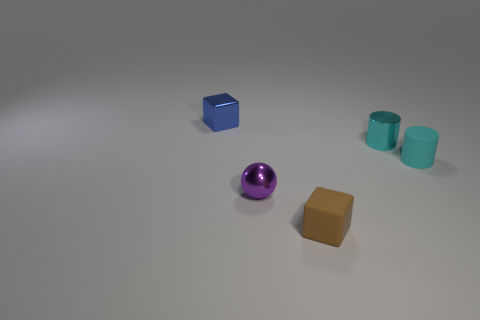How many other things are the same shape as the tiny blue thing?
Ensure brevity in your answer.  1. The small shiny object that is both on the left side of the matte cube and behind the tiny shiny sphere has what shape?
Your answer should be very brief. Cube. Are there any small cylinders left of the tiny cyan matte thing?
Make the answer very short. Yes. There is another matte object that is the same shape as the blue object; what is its size?
Keep it short and to the point. Small. Are there any other things that have the same size as the cyan rubber cylinder?
Keep it short and to the point. Yes. Does the blue object have the same shape as the tiny cyan rubber object?
Your response must be concise. No. There is a cyan cylinder that is to the left of the small matte object that is right of the small brown matte cube; how big is it?
Offer a terse response. Small. What color is the metal object that is the same shape as the cyan matte object?
Give a very brief answer. Cyan. What number of small metallic cylinders are the same color as the shiny block?
Make the answer very short. 0. How big is the purple shiny object?
Your answer should be very brief. Small. 